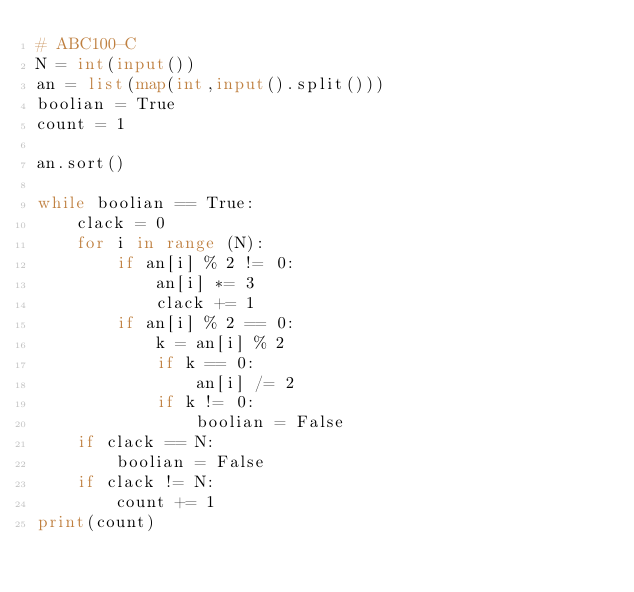Convert code to text. <code><loc_0><loc_0><loc_500><loc_500><_Python_># ABC100-C
N = int(input())
an = list(map(int,input().split()))
boolian = True
count = 1

an.sort()

while boolian == True:
    clack = 0
    for i in range (N):
        if an[i] % 2 != 0:
            an[i] *= 3 
            clack += 1
        if an[i] % 2 == 0:
            k = an[i] % 2
            if k == 0:
                an[i] /= 2 
            if k != 0:
                boolian = False
    if clack == N:
        boolian = False
    if clack != N:
        count += 1               
print(count)
        </code> 